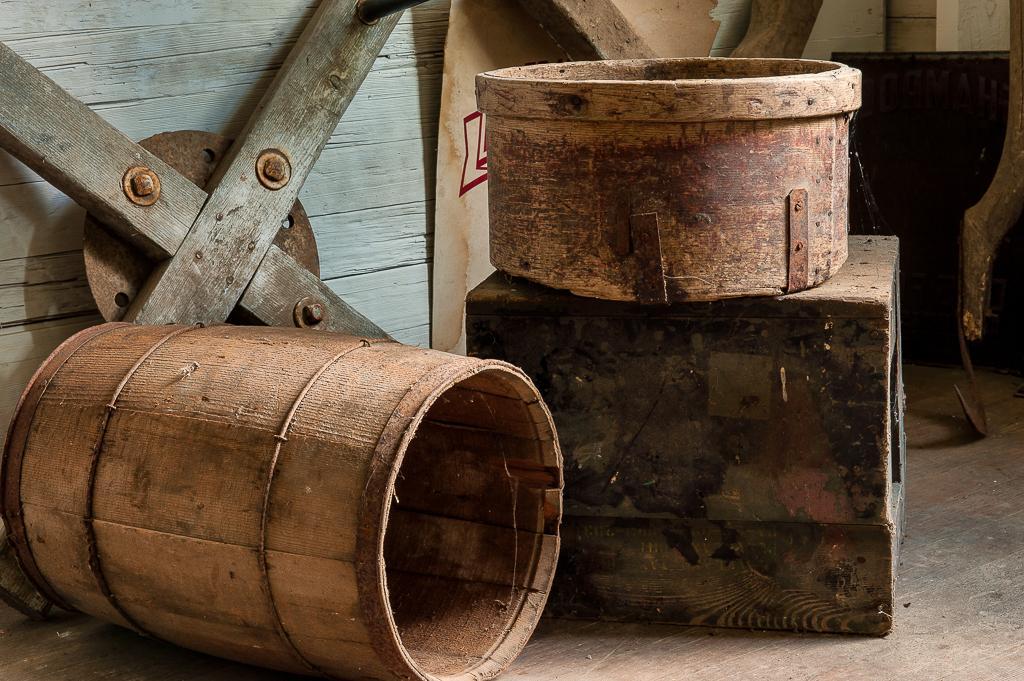In one or two sentences, can you explain what this image depicts? In this image I can see wooden barrel, box and some other wooden objects on the floor. 